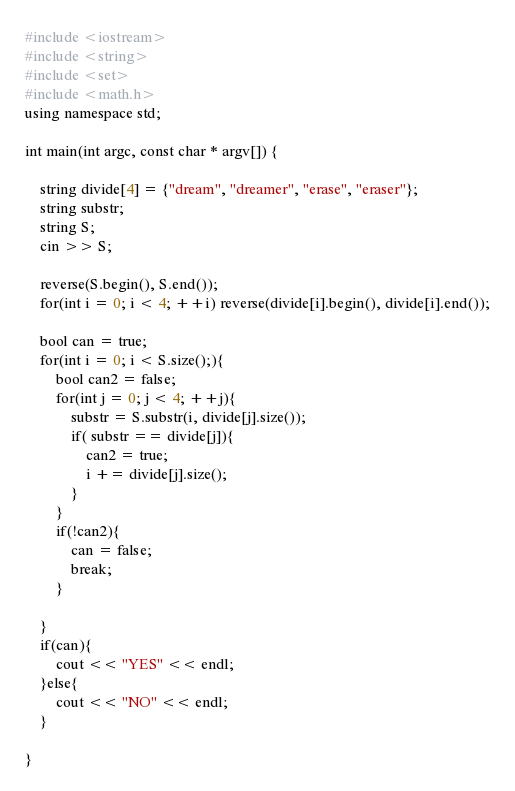<code> <loc_0><loc_0><loc_500><loc_500><_C++_>#include <iostream>
#include <string>
#include <set>
#include <math.h>
using namespace std;

int main(int argc, const char * argv[]) {

    string divide[4] = {"dream", "dreamer", "erase", "eraser"};
    string substr;
    string S;
    cin >> S;

    reverse(S.begin(), S.end());
    for(int i = 0; i < 4; ++i) reverse(divide[i].begin(), divide[i].end());

    bool can = true;
    for(int i = 0; i < S.size();){
        bool can2 = false;
        for(int j = 0; j < 4; ++j){
            substr = S.substr(i, divide[j].size());
            if( substr == divide[j]){
                can2 = true;
                i += divide[j].size();
            }
        }
        if(!can2){
            can = false;
            break;
        }

    }
    if(can){
        cout << "YES" << endl;
    }else{
        cout << "NO" << endl;
    }

}</code> 